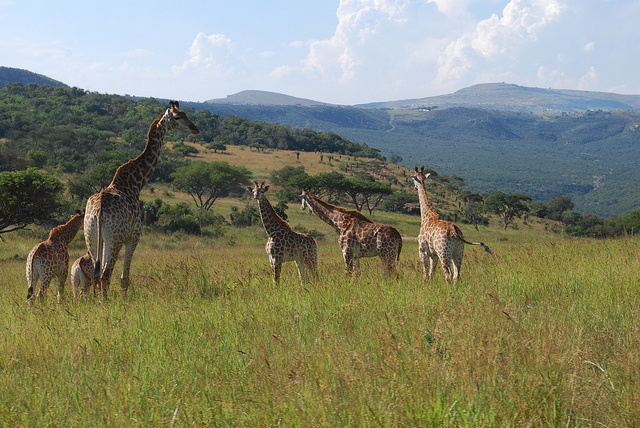Describe the objects in this image and their specific colors. I can see giraffe in lavender, black, and gray tones, giraffe in lavender, black, maroon, and gray tones, giraffe in lavender, black, and gray tones, giraffe in lavender, gray, and tan tones, and giraffe in lavender, black, olive, and gray tones in this image. 